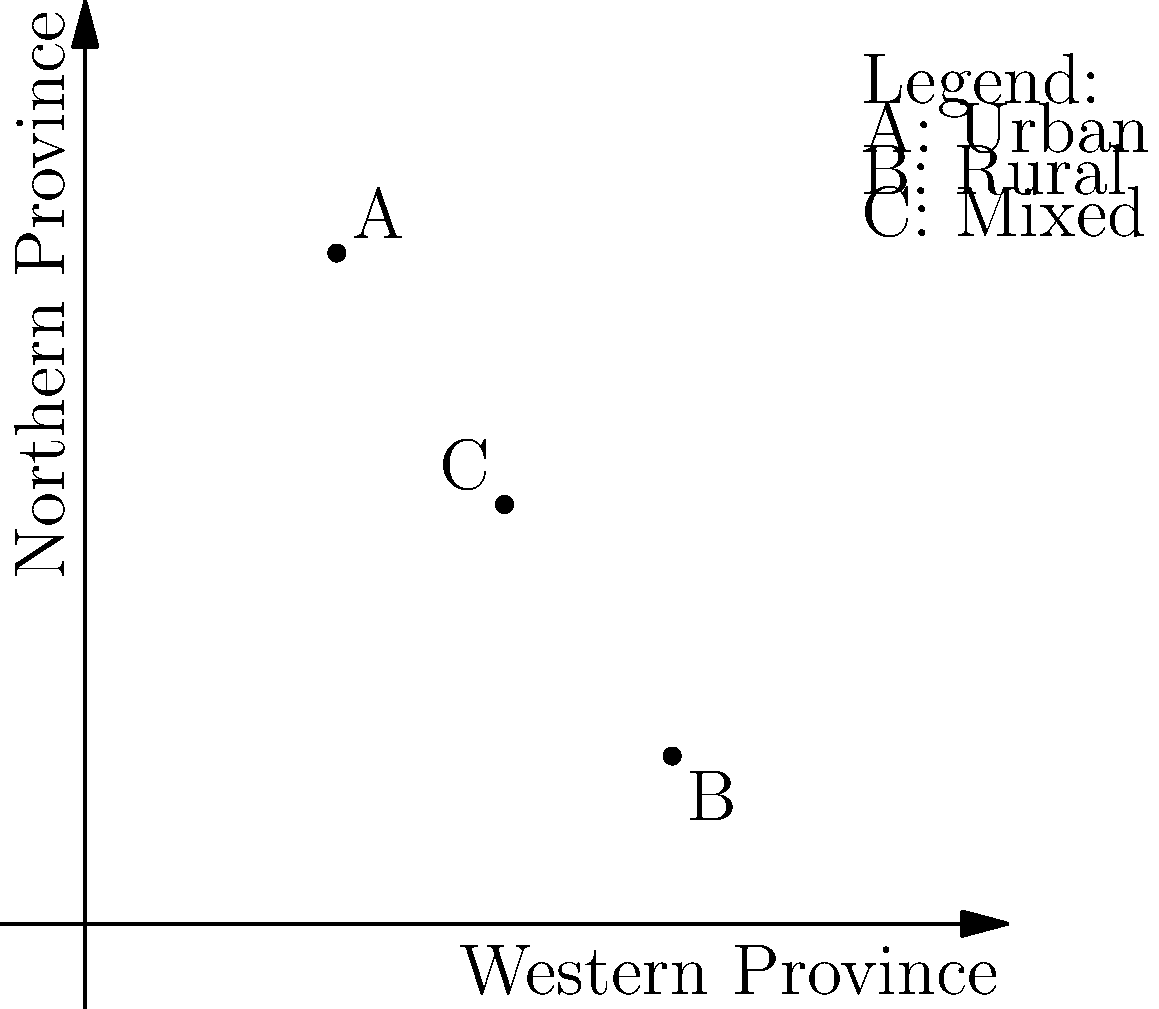In the given 2D coordinate plane, three points A, B, and C represent different voter distributions in Sri Lankan provinces. The x-axis represents the Western Province, and the y-axis represents the Northern Province. Point A (3,8) represents urban voters, B (7,2) represents rural voters, and C (5,5) represents mixed voters. Which point has the most balanced distribution of voters between the Western and Northern Provinces? To determine the most balanced distribution of voters between the Western and Northern Provinces, we need to analyze the coordinates of each point:

1. Point A (3,8):
   - Western Province: 3
   - Northern Province: 8
   - Difference: |3 - 8| = 5

2. Point B (7,2):
   - Western Province: 7
   - Northern Province: 2
   - Difference: |7 - 2| = 5

3. Point C (5,5):
   - Western Province: 5
   - Northern Province: 5
   - Difference: |5 - 5| = 0

The point with the smallest difference between its x and y coordinates represents the most balanced distribution. Point C has equal values for both provinces, making it the most balanced.
Answer: C (5,5) 